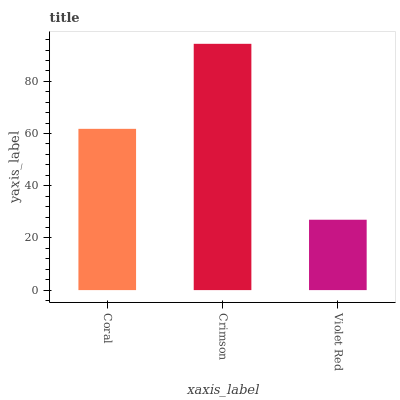Is Violet Red the minimum?
Answer yes or no. Yes. Is Crimson the maximum?
Answer yes or no. Yes. Is Crimson the minimum?
Answer yes or no. No. Is Violet Red the maximum?
Answer yes or no. No. Is Crimson greater than Violet Red?
Answer yes or no. Yes. Is Violet Red less than Crimson?
Answer yes or no. Yes. Is Violet Red greater than Crimson?
Answer yes or no. No. Is Crimson less than Violet Red?
Answer yes or no. No. Is Coral the high median?
Answer yes or no. Yes. Is Coral the low median?
Answer yes or no. Yes. Is Violet Red the high median?
Answer yes or no. No. Is Violet Red the low median?
Answer yes or no. No. 